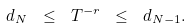Convert formula to latex. <formula><loc_0><loc_0><loc_500><loc_500>d _ { N } \ \leq \ T ^ { - r } \ \leq \ d _ { N - 1 } .</formula> 